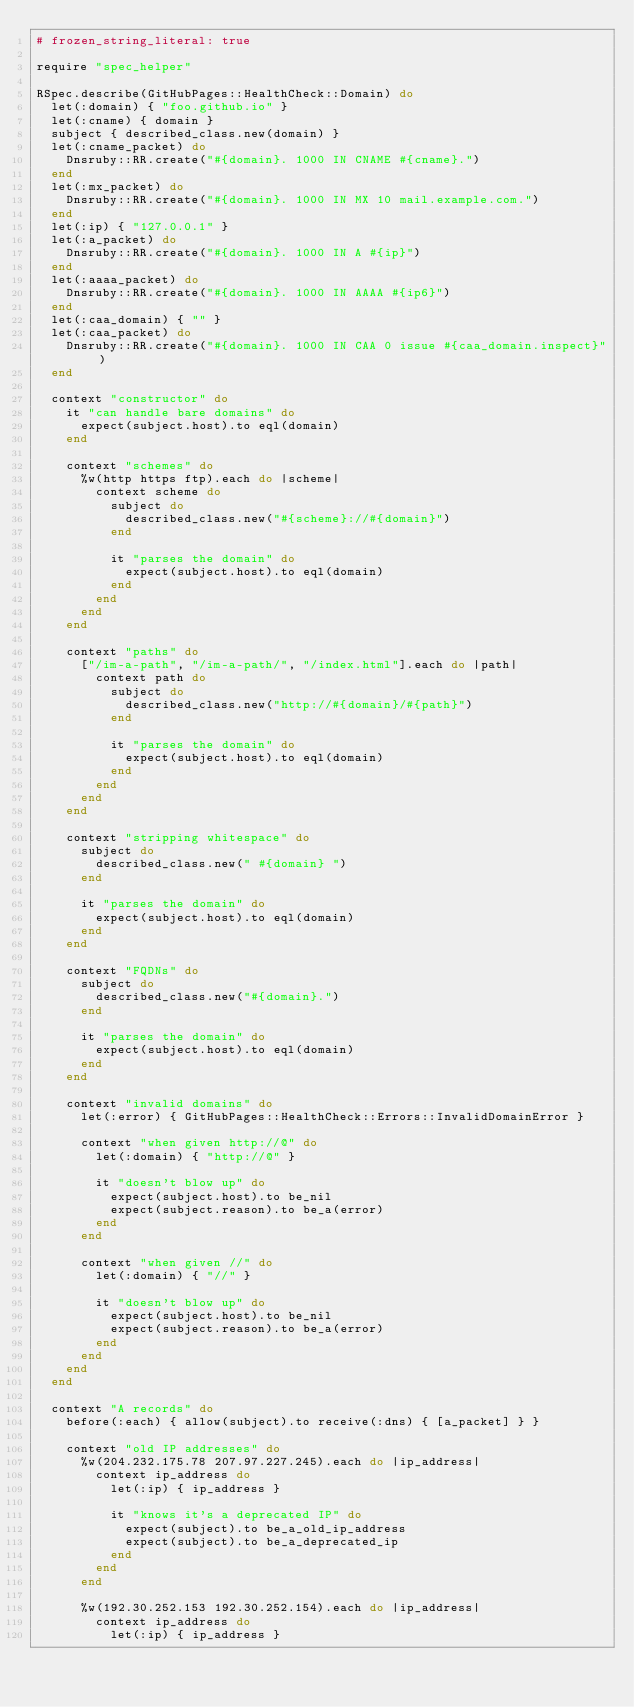Convert code to text. <code><loc_0><loc_0><loc_500><loc_500><_Ruby_># frozen_string_literal: true

require "spec_helper"

RSpec.describe(GitHubPages::HealthCheck::Domain) do
  let(:domain) { "foo.github.io" }
  let(:cname) { domain }
  subject { described_class.new(domain) }
  let(:cname_packet) do
    Dnsruby::RR.create("#{domain}. 1000 IN CNAME #{cname}.")
  end
  let(:mx_packet) do
    Dnsruby::RR.create("#{domain}. 1000 IN MX 10 mail.example.com.")
  end
  let(:ip) { "127.0.0.1" }
  let(:a_packet) do
    Dnsruby::RR.create("#{domain}. 1000 IN A #{ip}")
  end
  let(:aaaa_packet) do
    Dnsruby::RR.create("#{domain}. 1000 IN AAAA #{ip6}")
  end
  let(:caa_domain) { "" }
  let(:caa_packet) do
    Dnsruby::RR.create("#{domain}. 1000 IN CAA 0 issue #{caa_domain.inspect}")
  end

  context "constructor" do
    it "can handle bare domains" do
      expect(subject.host).to eql(domain)
    end

    context "schemes" do
      %w(http https ftp).each do |scheme|
        context scheme do
          subject do
            described_class.new("#{scheme}://#{domain}")
          end

          it "parses the domain" do
            expect(subject.host).to eql(domain)
          end
        end
      end
    end

    context "paths" do
      ["/im-a-path", "/im-a-path/", "/index.html"].each do |path|
        context path do
          subject do
            described_class.new("http://#{domain}/#{path}")
          end

          it "parses the domain" do
            expect(subject.host).to eql(domain)
          end
        end
      end
    end

    context "stripping whitespace" do
      subject do
        described_class.new(" #{domain} ")
      end

      it "parses the domain" do
        expect(subject.host).to eql(domain)
      end
    end

    context "FQDNs" do
      subject do
        described_class.new("#{domain}.")
      end

      it "parses the domain" do
        expect(subject.host).to eql(domain)
      end
    end

    context "invalid domains" do
      let(:error) { GitHubPages::HealthCheck::Errors::InvalidDomainError }

      context "when given http://@" do
        let(:domain) { "http://@" }

        it "doesn't blow up" do
          expect(subject.host).to be_nil
          expect(subject.reason).to be_a(error)
        end
      end

      context "when given //" do
        let(:domain) { "//" }

        it "doesn't blow up" do
          expect(subject.host).to be_nil
          expect(subject.reason).to be_a(error)
        end
      end
    end
  end

  context "A records" do
    before(:each) { allow(subject).to receive(:dns) { [a_packet] } }

    context "old IP addresses" do
      %w(204.232.175.78 207.97.227.245).each do |ip_address|
        context ip_address do
          let(:ip) { ip_address }

          it "knows it's a deprecated IP" do
            expect(subject).to be_a_old_ip_address
            expect(subject).to be_a_deprecated_ip
          end
        end
      end

      %w(192.30.252.153 192.30.252.154).each do |ip_address|
        context ip_address do
          let(:ip) { ip_address }
</code> 